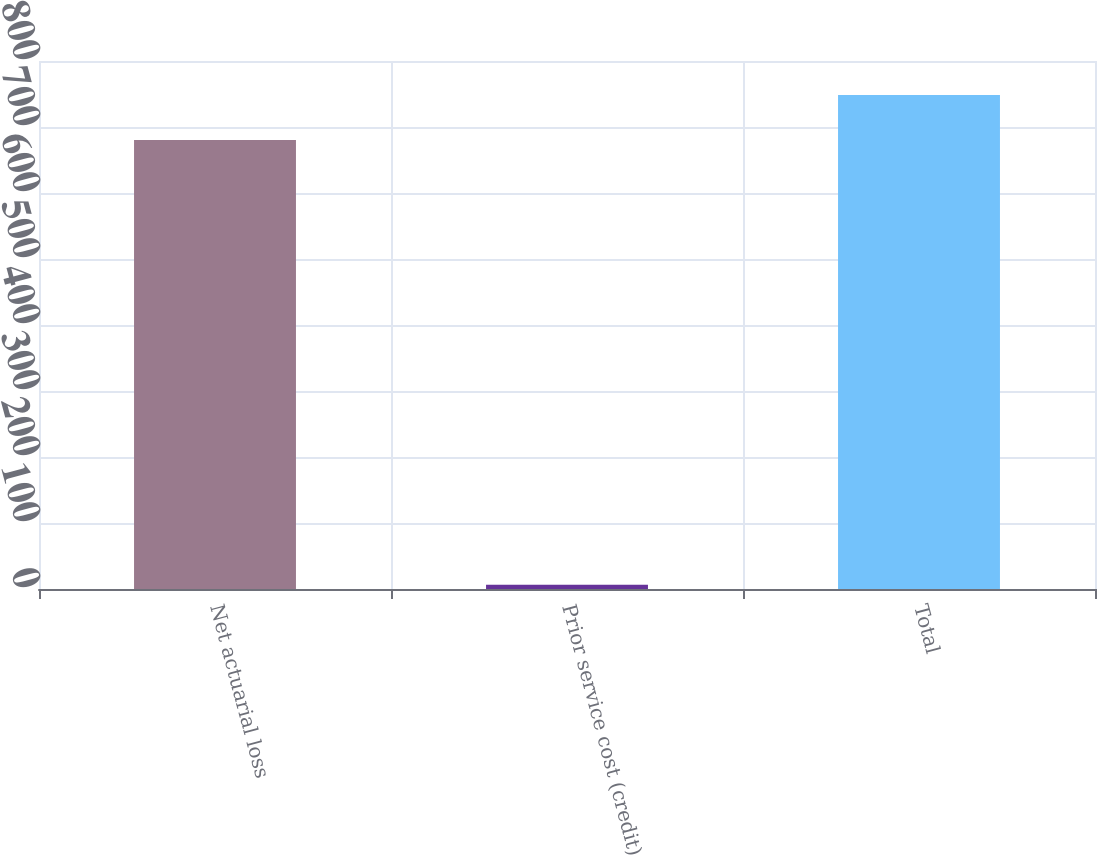Convert chart. <chart><loc_0><loc_0><loc_500><loc_500><bar_chart><fcel>Net actuarial loss<fcel>Prior service cost (credit)<fcel>Total<nl><fcel>680.4<fcel>6.6<fcel>748.44<nl></chart> 